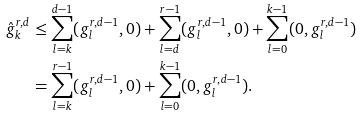<formula> <loc_0><loc_0><loc_500><loc_500>\hat { g } ^ { r , d } _ { k } & \leq \sum _ { l = k } ^ { d - 1 } ( g ^ { r , d - 1 } _ { l } , 0 ) + \sum _ { l = d } ^ { r - 1 } ( g ^ { r , d - 1 } _ { l } , 0 ) + \sum _ { l = 0 } ^ { k - 1 } ( 0 , g ^ { r , d - 1 } _ { l } ) \\ & = \sum _ { l = k } ^ { r - 1 } ( g ^ { r , d - 1 } _ { l } , 0 ) + \sum _ { l = 0 } ^ { k - 1 } ( 0 , g ^ { r , d - 1 } _ { l } ) .</formula> 